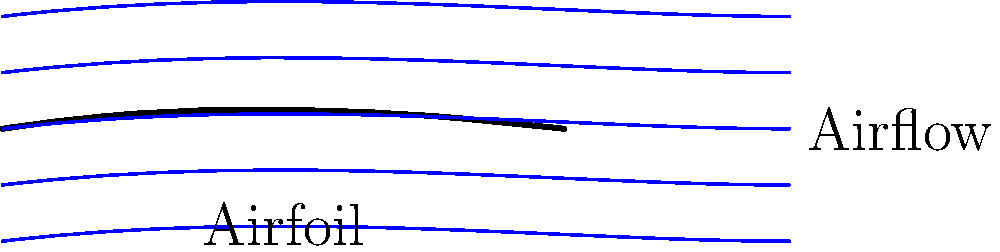In the telenovela "Vientos de Pasión," the handsome pilot Carlos must land his small plane on a remote island to rescue his lost love, Maria. Looking at the diagram of airflow around the wing, what characteristic of the streamlines above the airfoil suggests increased velocity compared to the streamlines below? To understand this concept, let's break it down step-by-step:

1. Streamlines represent the path of air particles moving around an object.

2. In this diagram, we see streamlines flowing around an airfoil (wing) shape.

3. Notice that the streamlines above the airfoil are closer together than those below.

4. This compression of streamlines indicates a key principle in fluid dynamics: the continuity equation. It states that for an incompressible flow, as the cross-sectional area decreases, the velocity must increase to maintain the same flow rate.

5. The closer spacing of streamlines above the airfoil represents a smaller effective cross-sectional area for the air to flow through.

6. According to the continuity equation:

   $$Q = A_1v_1 = A_2v_2$$

   Where $Q$ is the flow rate, $A$ is the cross-sectional area, and $v$ is the velocity.

7. If $A_2 < A_1$ (as we see above the airfoil), then $v_2 > v_1$ to maintain the same $Q$.

Therefore, the closer spacing of streamlines above the airfoil indicates a higher velocity compared to the more spread out streamlines below.
Answer: Closer spacing of streamlines 